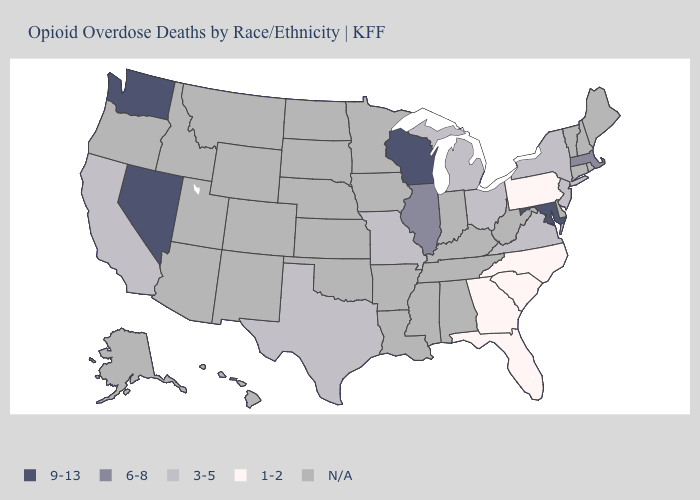What is the lowest value in the South?
Short answer required. 1-2. Name the states that have a value in the range 1-2?
Be succinct. Florida, Georgia, North Carolina, Pennsylvania, South Carolina. Name the states that have a value in the range 3-5?
Be succinct. California, Michigan, Missouri, New Jersey, New York, Ohio, Texas, Virginia. What is the value of Rhode Island?
Write a very short answer. N/A. What is the highest value in the Northeast ?
Quick response, please. 6-8. Name the states that have a value in the range 1-2?
Quick response, please. Florida, Georgia, North Carolina, Pennsylvania, South Carolina. Name the states that have a value in the range 1-2?
Write a very short answer. Florida, Georgia, North Carolina, Pennsylvania, South Carolina. Name the states that have a value in the range 9-13?
Keep it brief. Maryland, Nevada, Washington, Wisconsin. Which states have the lowest value in the USA?
Be succinct. Florida, Georgia, North Carolina, Pennsylvania, South Carolina. Name the states that have a value in the range 3-5?
Concise answer only. California, Michigan, Missouri, New Jersey, New York, Ohio, Texas, Virginia. What is the value of Arkansas?
Answer briefly. N/A. What is the lowest value in the USA?
Be succinct. 1-2. What is the value of North Carolina?
Answer briefly. 1-2. 